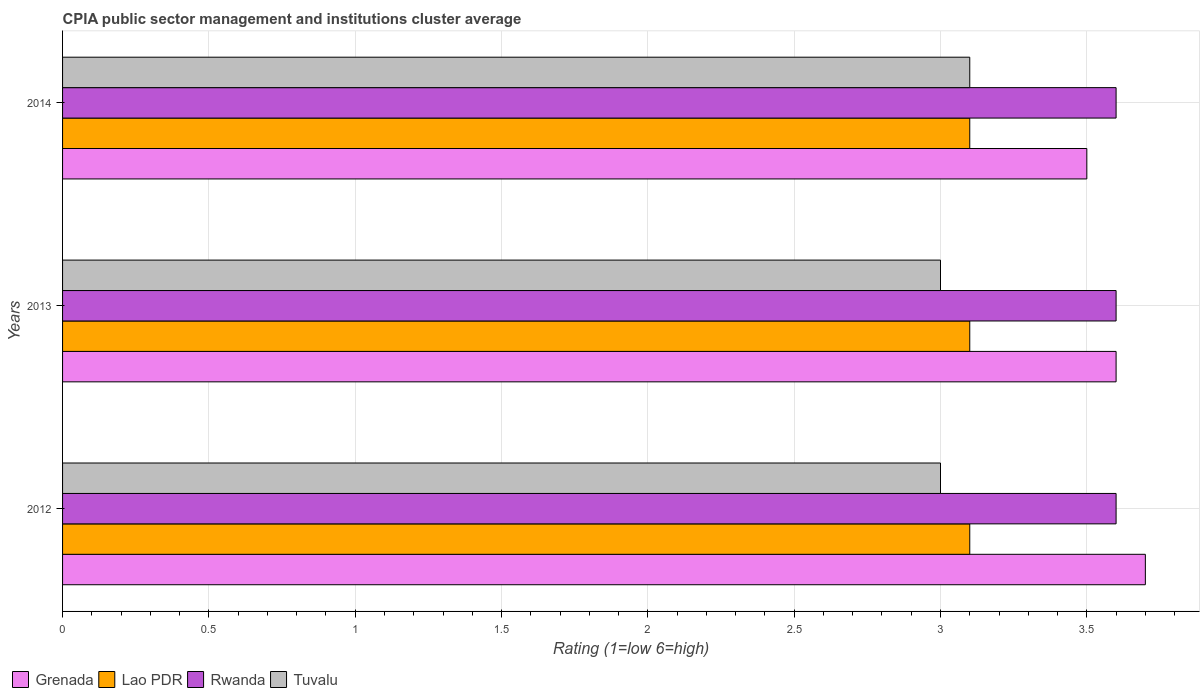Are the number of bars on each tick of the Y-axis equal?
Your answer should be very brief. Yes. What is the label of the 3rd group of bars from the top?
Offer a terse response. 2012. In how many cases, is the number of bars for a given year not equal to the number of legend labels?
Keep it short and to the point. 0. Across all years, what is the minimum CPIA rating in Lao PDR?
Offer a very short reply. 3.1. In which year was the CPIA rating in Lao PDR maximum?
Offer a terse response. 2012. In which year was the CPIA rating in Rwanda minimum?
Make the answer very short. 2012. What is the difference between the CPIA rating in Grenada in 2012 and that in 2014?
Offer a terse response. 0.2. What is the difference between the CPIA rating in Tuvalu in 2013 and the CPIA rating in Rwanda in 2012?
Keep it short and to the point. -0.6. In the year 2013, what is the difference between the CPIA rating in Lao PDR and CPIA rating in Tuvalu?
Provide a succinct answer. 0.1. In how many years, is the CPIA rating in Grenada greater than 1.2 ?
Give a very brief answer. 3. Is the CPIA rating in Grenada in 2012 less than that in 2014?
Make the answer very short. No. Is the difference between the CPIA rating in Lao PDR in 2012 and 2014 greater than the difference between the CPIA rating in Tuvalu in 2012 and 2014?
Provide a short and direct response. Yes. In how many years, is the CPIA rating in Rwanda greater than the average CPIA rating in Rwanda taken over all years?
Your answer should be compact. 0. Is the sum of the CPIA rating in Rwanda in 2013 and 2014 greater than the maximum CPIA rating in Lao PDR across all years?
Offer a very short reply. Yes. Is it the case that in every year, the sum of the CPIA rating in Tuvalu and CPIA rating in Lao PDR is greater than the sum of CPIA rating in Grenada and CPIA rating in Rwanda?
Offer a terse response. No. What does the 1st bar from the top in 2013 represents?
Provide a short and direct response. Tuvalu. What does the 2nd bar from the bottom in 2014 represents?
Provide a succinct answer. Lao PDR. Is it the case that in every year, the sum of the CPIA rating in Tuvalu and CPIA rating in Lao PDR is greater than the CPIA rating in Rwanda?
Offer a very short reply. Yes. How many bars are there?
Give a very brief answer. 12. Are all the bars in the graph horizontal?
Ensure brevity in your answer.  Yes. How many years are there in the graph?
Give a very brief answer. 3. What is the difference between two consecutive major ticks on the X-axis?
Ensure brevity in your answer.  0.5. Does the graph contain grids?
Offer a terse response. Yes. How many legend labels are there?
Provide a succinct answer. 4. What is the title of the graph?
Your response must be concise. CPIA public sector management and institutions cluster average. Does "Haiti" appear as one of the legend labels in the graph?
Provide a succinct answer. No. What is the label or title of the X-axis?
Your response must be concise. Rating (1=low 6=high). What is the label or title of the Y-axis?
Make the answer very short. Years. What is the Rating (1=low 6=high) in Rwanda in 2012?
Provide a short and direct response. 3.6. What is the Rating (1=low 6=high) of Tuvalu in 2012?
Your answer should be compact. 3. What is the Rating (1=low 6=high) of Grenada in 2014?
Provide a succinct answer. 3.5. What is the Rating (1=low 6=high) in Tuvalu in 2014?
Offer a very short reply. 3.1. Across all years, what is the maximum Rating (1=low 6=high) in Grenada?
Keep it short and to the point. 3.7. Across all years, what is the maximum Rating (1=low 6=high) of Tuvalu?
Keep it short and to the point. 3.1. Across all years, what is the minimum Rating (1=low 6=high) of Lao PDR?
Your answer should be compact. 3.1. Across all years, what is the minimum Rating (1=low 6=high) in Rwanda?
Your response must be concise. 3.6. Across all years, what is the minimum Rating (1=low 6=high) in Tuvalu?
Offer a terse response. 3. What is the total Rating (1=low 6=high) in Grenada in the graph?
Provide a succinct answer. 10.8. What is the total Rating (1=low 6=high) of Tuvalu in the graph?
Ensure brevity in your answer.  9.1. What is the difference between the Rating (1=low 6=high) of Grenada in 2012 and that in 2013?
Make the answer very short. 0.1. What is the difference between the Rating (1=low 6=high) in Rwanda in 2012 and that in 2013?
Ensure brevity in your answer.  0. What is the difference between the Rating (1=low 6=high) in Tuvalu in 2012 and that in 2013?
Offer a terse response. 0. What is the difference between the Rating (1=low 6=high) in Grenada in 2012 and that in 2014?
Keep it short and to the point. 0.2. What is the difference between the Rating (1=low 6=high) in Grenada in 2013 and that in 2014?
Provide a succinct answer. 0.1. What is the difference between the Rating (1=low 6=high) in Lao PDR in 2013 and that in 2014?
Your response must be concise. 0. What is the difference between the Rating (1=low 6=high) of Tuvalu in 2013 and that in 2014?
Offer a terse response. -0.1. What is the difference between the Rating (1=low 6=high) of Grenada in 2012 and the Rating (1=low 6=high) of Rwanda in 2013?
Offer a very short reply. 0.1. What is the difference between the Rating (1=low 6=high) in Lao PDR in 2012 and the Rating (1=low 6=high) in Rwanda in 2013?
Provide a succinct answer. -0.5. What is the difference between the Rating (1=low 6=high) of Grenada in 2012 and the Rating (1=low 6=high) of Tuvalu in 2014?
Make the answer very short. 0.6. What is the difference between the Rating (1=low 6=high) of Lao PDR in 2012 and the Rating (1=low 6=high) of Rwanda in 2014?
Your answer should be compact. -0.5. What is the difference between the Rating (1=low 6=high) of Lao PDR in 2012 and the Rating (1=low 6=high) of Tuvalu in 2014?
Keep it short and to the point. 0. What is the difference between the Rating (1=low 6=high) in Rwanda in 2012 and the Rating (1=low 6=high) in Tuvalu in 2014?
Your answer should be very brief. 0.5. What is the difference between the Rating (1=low 6=high) in Grenada in 2013 and the Rating (1=low 6=high) in Lao PDR in 2014?
Offer a terse response. 0.5. What is the difference between the Rating (1=low 6=high) in Lao PDR in 2013 and the Rating (1=low 6=high) in Tuvalu in 2014?
Offer a very short reply. 0. What is the difference between the Rating (1=low 6=high) in Rwanda in 2013 and the Rating (1=low 6=high) in Tuvalu in 2014?
Keep it short and to the point. 0.5. What is the average Rating (1=low 6=high) in Grenada per year?
Your response must be concise. 3.6. What is the average Rating (1=low 6=high) in Tuvalu per year?
Keep it short and to the point. 3.03. In the year 2012, what is the difference between the Rating (1=low 6=high) of Grenada and Rating (1=low 6=high) of Lao PDR?
Provide a short and direct response. 0.6. In the year 2012, what is the difference between the Rating (1=low 6=high) in Lao PDR and Rating (1=low 6=high) in Rwanda?
Give a very brief answer. -0.5. In the year 2012, what is the difference between the Rating (1=low 6=high) of Rwanda and Rating (1=low 6=high) of Tuvalu?
Ensure brevity in your answer.  0.6. In the year 2013, what is the difference between the Rating (1=low 6=high) of Grenada and Rating (1=low 6=high) of Lao PDR?
Provide a succinct answer. 0.5. In the year 2013, what is the difference between the Rating (1=low 6=high) in Grenada and Rating (1=low 6=high) in Tuvalu?
Provide a succinct answer. 0.6. In the year 2013, what is the difference between the Rating (1=low 6=high) in Rwanda and Rating (1=low 6=high) in Tuvalu?
Keep it short and to the point. 0.6. In the year 2014, what is the difference between the Rating (1=low 6=high) of Grenada and Rating (1=low 6=high) of Tuvalu?
Offer a terse response. 0.4. In the year 2014, what is the difference between the Rating (1=low 6=high) of Lao PDR and Rating (1=low 6=high) of Rwanda?
Your response must be concise. -0.5. In the year 2014, what is the difference between the Rating (1=low 6=high) in Rwanda and Rating (1=low 6=high) in Tuvalu?
Your answer should be compact. 0.5. What is the ratio of the Rating (1=low 6=high) in Grenada in 2012 to that in 2013?
Your response must be concise. 1.03. What is the ratio of the Rating (1=low 6=high) of Tuvalu in 2012 to that in 2013?
Your response must be concise. 1. What is the ratio of the Rating (1=low 6=high) in Grenada in 2012 to that in 2014?
Your answer should be very brief. 1.06. What is the ratio of the Rating (1=low 6=high) of Lao PDR in 2012 to that in 2014?
Offer a terse response. 1. What is the ratio of the Rating (1=low 6=high) in Tuvalu in 2012 to that in 2014?
Provide a succinct answer. 0.97. What is the ratio of the Rating (1=low 6=high) of Grenada in 2013 to that in 2014?
Provide a succinct answer. 1.03. What is the ratio of the Rating (1=low 6=high) in Lao PDR in 2013 to that in 2014?
Your response must be concise. 1. What is the ratio of the Rating (1=low 6=high) in Rwanda in 2013 to that in 2014?
Offer a terse response. 1. What is the difference between the highest and the second highest Rating (1=low 6=high) in Lao PDR?
Offer a very short reply. 0. What is the difference between the highest and the lowest Rating (1=low 6=high) in Grenada?
Keep it short and to the point. 0.2. 